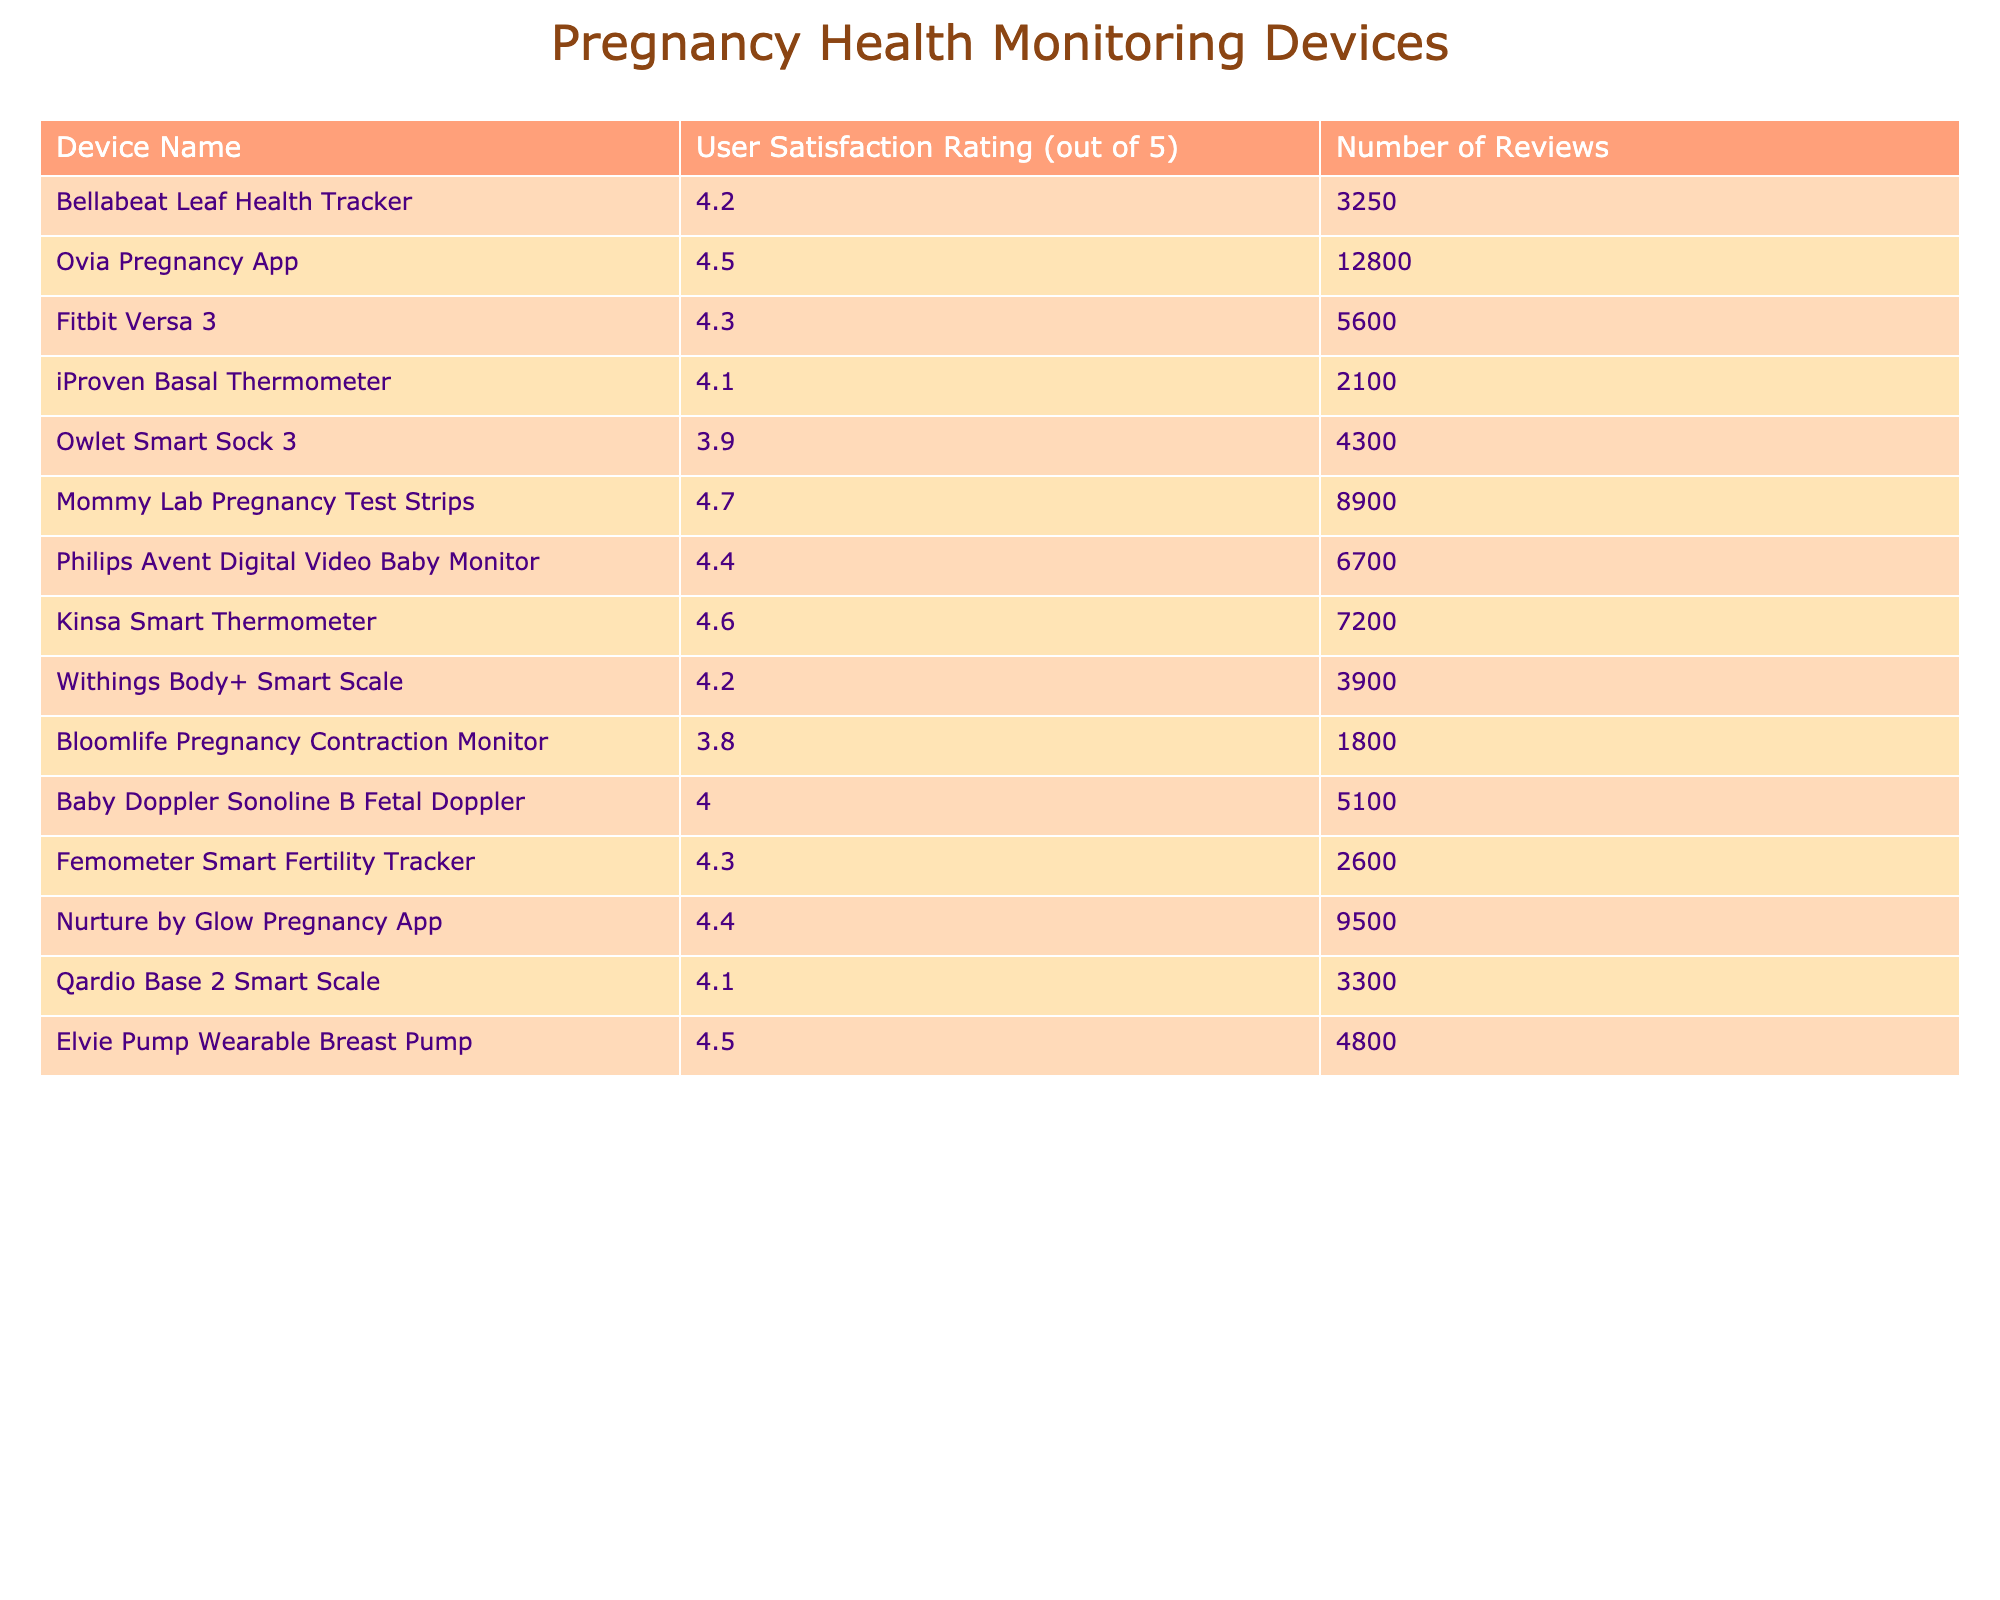What is the user satisfaction rating for the Mommy Lab Pregnancy Test Strips? The table states that the user satisfaction rating for the Mommy Lab Pregnancy Test Strips is 4.7.
Answer: 4.7 Which device has the lowest user satisfaction rating? The table shows that the Bloomlife Pregnancy Contraction Monitor has the lowest user satisfaction rating at 3.8.
Answer: Bloomlife Pregnancy Contraction Monitor How many reviews were there for the Philips Avent Digital Video Baby Monitor? According to the table, there were 6700 reviews for the Philips Avent Digital Video Baby Monitor.
Answer: 6700 What is the average user satisfaction rating of all listed devices? To find the average, add all satisfaction ratings (4.2+4.5+4.3+4.1+3.9+4.7+4.4+4.6+4.2+3.8+4.0+4.3+4.4+4.1+4.5) = 63.5. There are 15 devices, so the average is 63.5 / 15 = 4.23.
Answer: 4.23 Is the user satisfaction rating for the Elvie Pump Wearable Breast Pump higher than 4.4? The table indicates that the user satisfaction rating for the Elvie Pump Wearable Breast Pump is 4.5, which is indeed higher than 4.4.
Answer: Yes Which device has the highest number of reviews? From the table, the Ovia Pregnancy App has the highest number of reviews, totaling 12800.
Answer: Ovia Pregnancy App How many devices have a user satisfaction rating of 4.4 or higher? By reviewing the table, we find that the following devices have ratings of 4.4 or higher: Ovia Pregnancy App, Mommy Lab Pregnancy Test Strips, Kinsa Smart Thermometer, Nurture by Glow Pregnancy App, Elvie Pump Wearable Breast Pump, and Philips Avent Digital Video Baby Monitor. This amounts to 6 devices.
Answer: 6 What is the satisfaction rating difference between the Bellabeat Leaf Health Tracker and the Owlet Smart Sock 3? The Bellabeat Leaf Health Tracker has a rating of 4.2, and the Owlet Smart Sock 3 has a rating of 3.9. The difference is 4.2 - 3.9 = 0.3.
Answer: 0.3 What percentage of the devices have a satisfaction rating below 4.0? The only device below 4.0 is the Bloomlife Pregnancy Contraction Monitor and the Owlet Smart Sock 3. As there are 15 devices total, 2 out of 15 is approximately 13.33%, so about 13% of the devices have ratings below 4.0.
Answer: 13% 